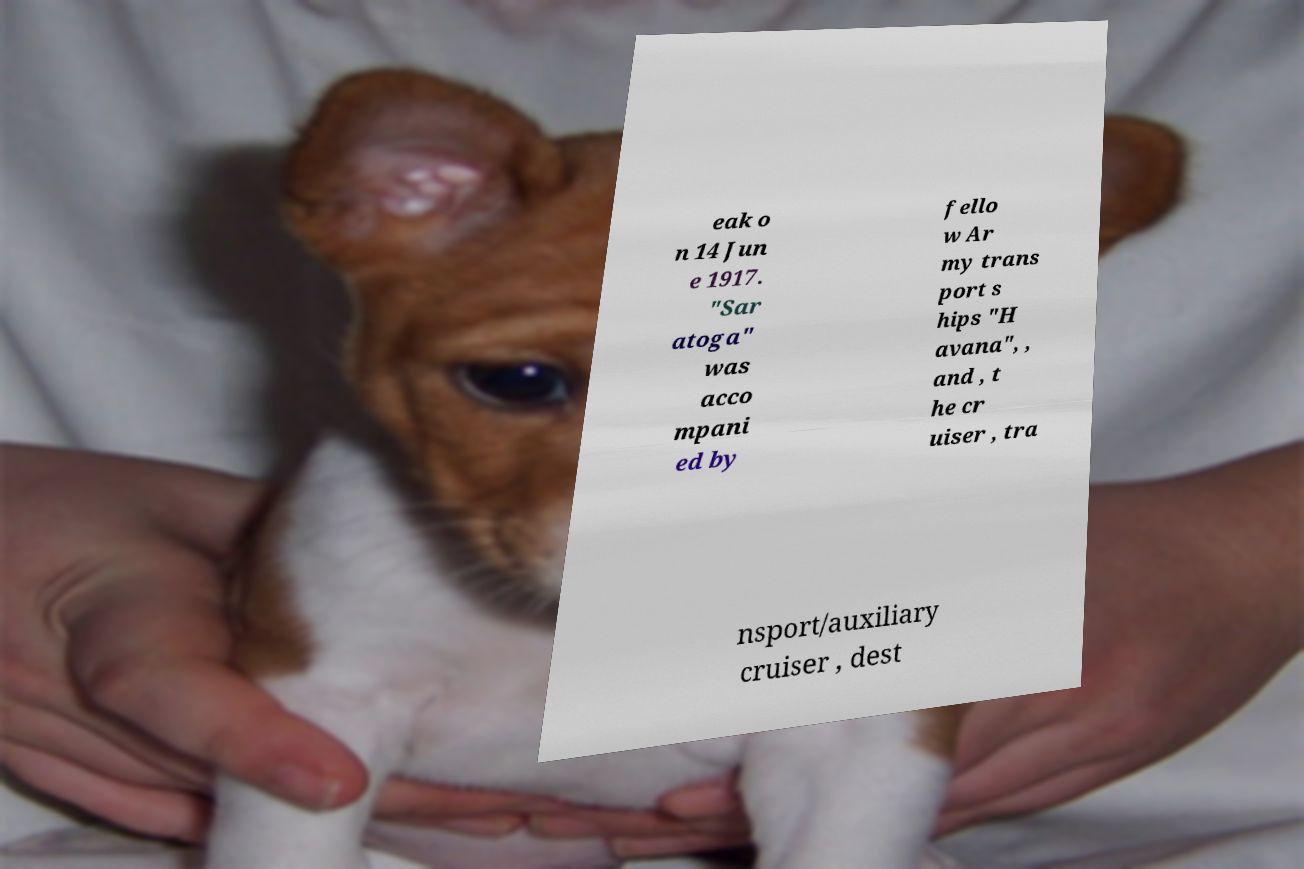Could you assist in decoding the text presented in this image and type it out clearly? eak o n 14 Jun e 1917. "Sar atoga" was acco mpani ed by fello w Ar my trans port s hips "H avana", , and , t he cr uiser , tra nsport/auxiliary cruiser , dest 